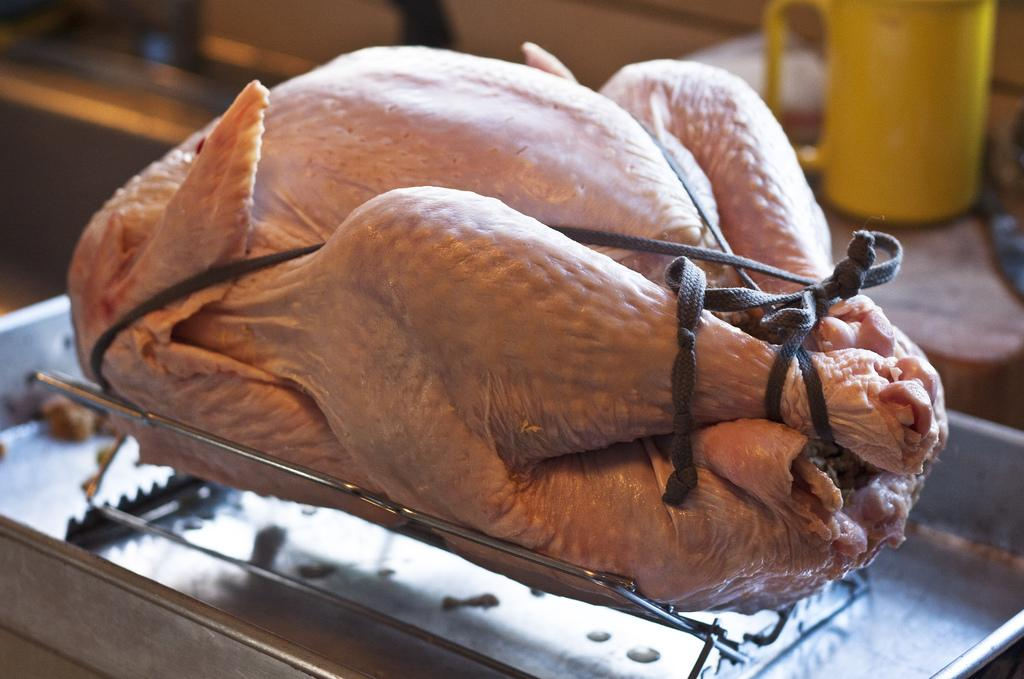What type of meat is present in the image? There is chicken meat in the image. How is the chicken meat arranged or secured? The chicken meat is tied with ropes. Where is the chicken meat placed? The chicken meat is placed in a tray. What can be seen in the background of the image? There is a cup and other objects visible in the background of the image. How many jellyfish are swimming in the soup on the stage in the image? There are no jellyfish, soup, or stage present in the image. 